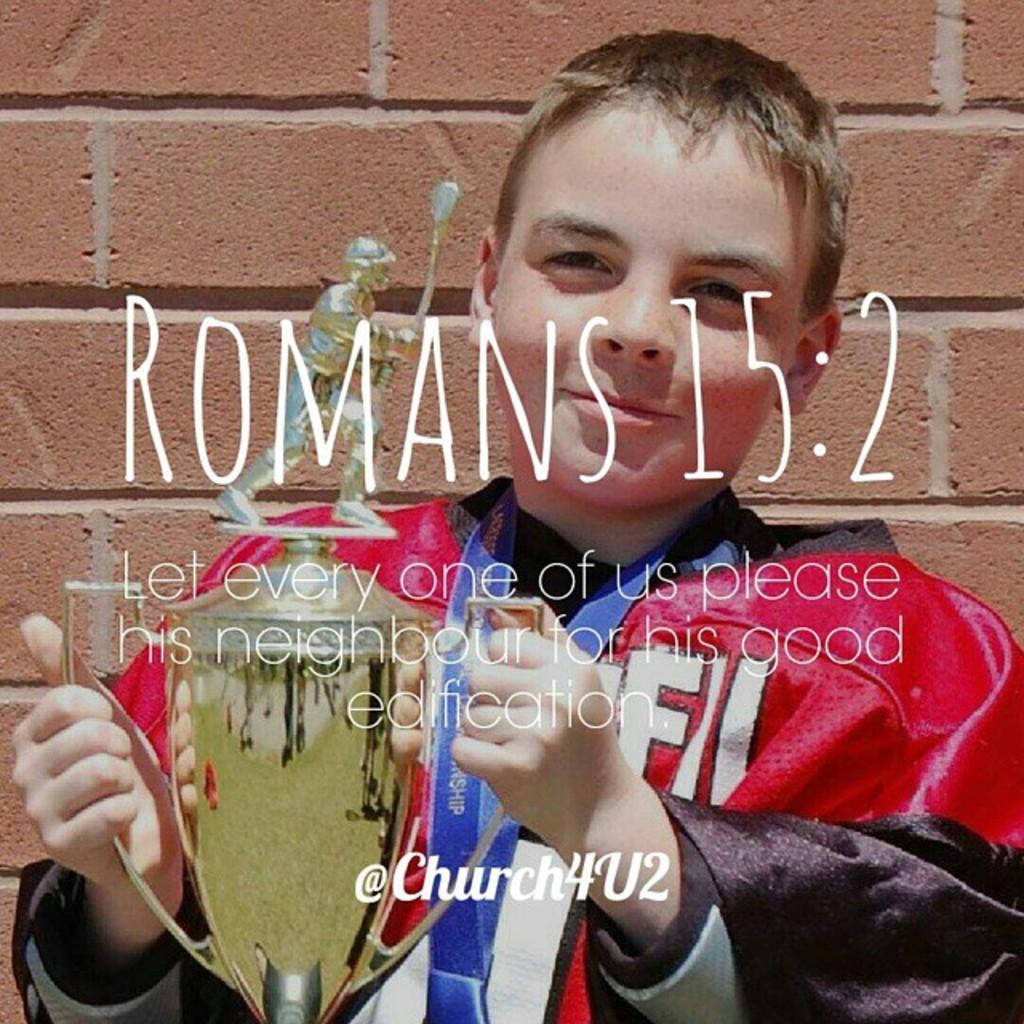What bible verse is being quoted?
Your answer should be compact. Romans 15:2. Who sponsored this pic/verse?
Ensure brevity in your answer.  Church4u2. 